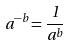<formula> <loc_0><loc_0><loc_500><loc_500>a ^ { - b } = \frac { 1 } { a ^ { b } }</formula> 